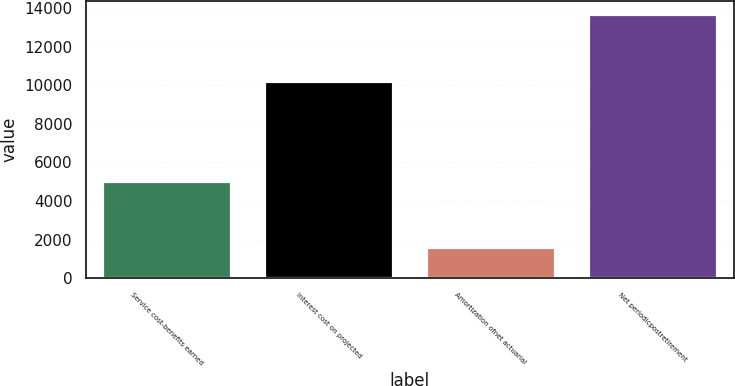<chart> <loc_0><loc_0><loc_500><loc_500><bar_chart><fcel>Service cost-benefits earned<fcel>Interest cost on projected<fcel>Amortization ofnet actuarial<fcel>Net periodicpostretirement<nl><fcel>5047<fcel>10238<fcel>1602<fcel>13683<nl></chart> 